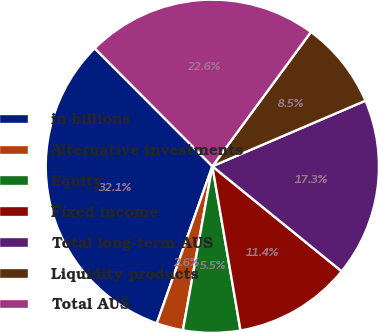Convert chart. <chart><loc_0><loc_0><loc_500><loc_500><pie_chart><fcel>in billions<fcel>Alternative investments<fcel>Equity<fcel>Fixed income<fcel>Total long-term AUS<fcel>Liquidity products<fcel>Total AUS<nl><fcel>32.11%<fcel>2.58%<fcel>5.53%<fcel>11.44%<fcel>17.3%<fcel>8.48%<fcel>22.56%<nl></chart> 